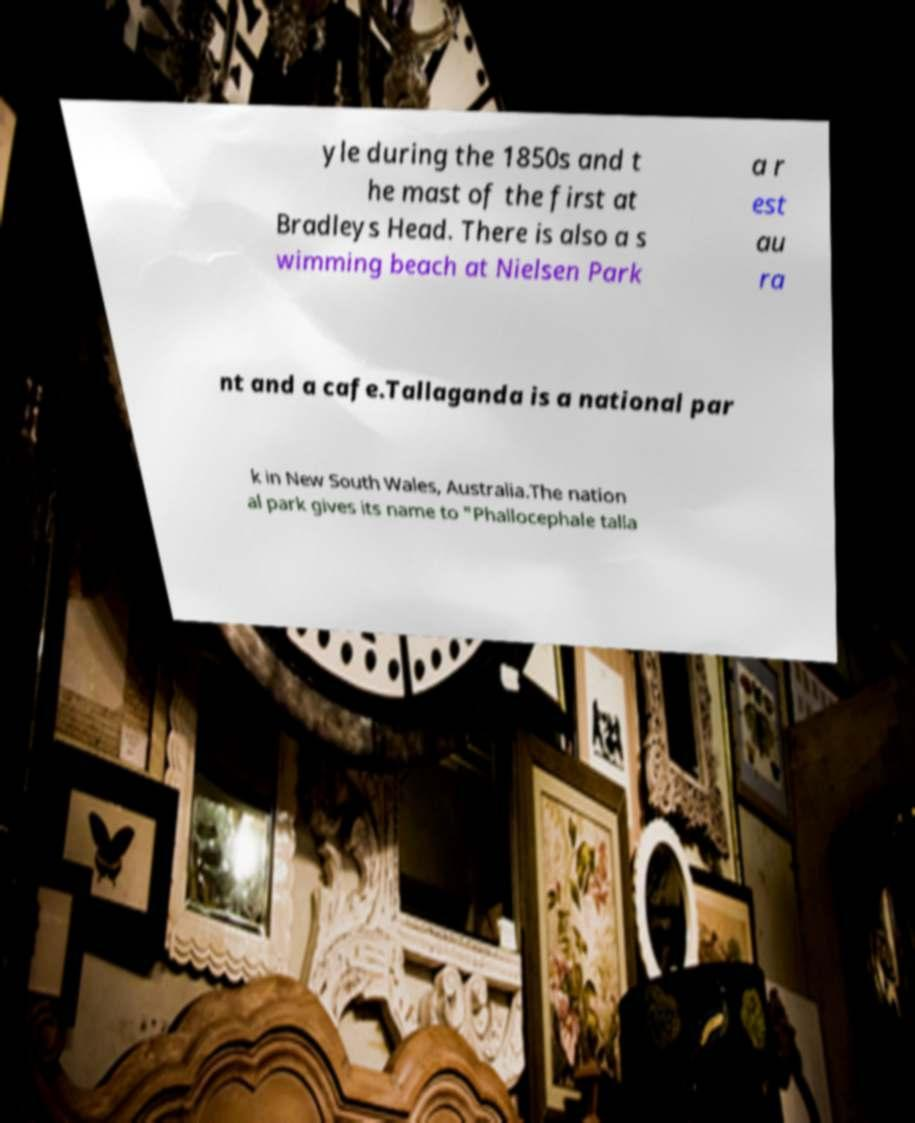Could you assist in decoding the text presented in this image and type it out clearly? yle during the 1850s and t he mast of the first at Bradleys Head. There is also a s wimming beach at Nielsen Park a r est au ra nt and a cafe.Tallaganda is a national par k in New South Wales, Australia.The nation al park gives its name to "Phallocephale talla 